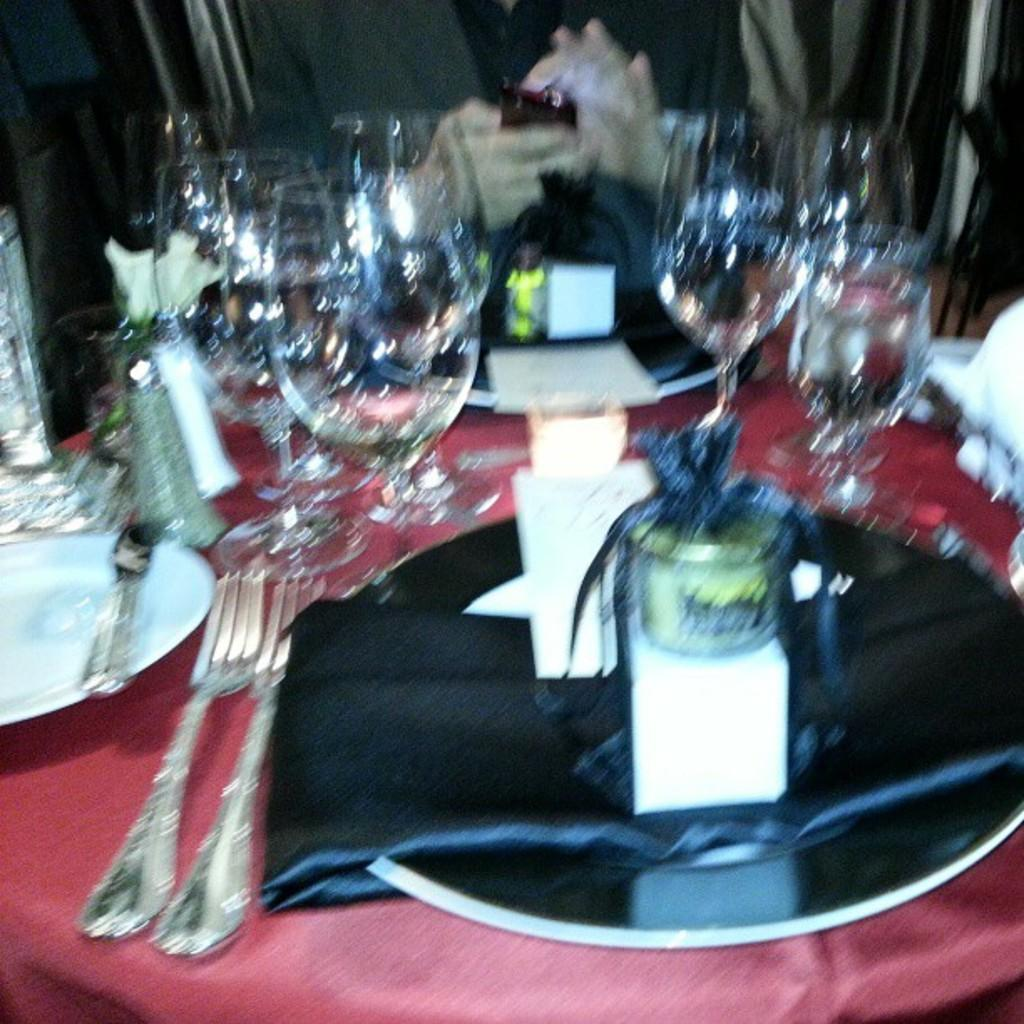What piece of furniture is present in the image? There is a table in the image. What is placed on the table? There is a tray, plates, forks, glasses, and a cloth on the table. What utensils are visible on the table? There are forks on the table. What type of dishware is present on the table? There are plates on the table. What is the person in the background of the image holding? The person in the background of the image is holding a mobile. What grade does the person in the image receive for their hospital room cleanliness? There is no hospital or grade present in the image; it features a table with various items and a person holding a mobile in the background. 